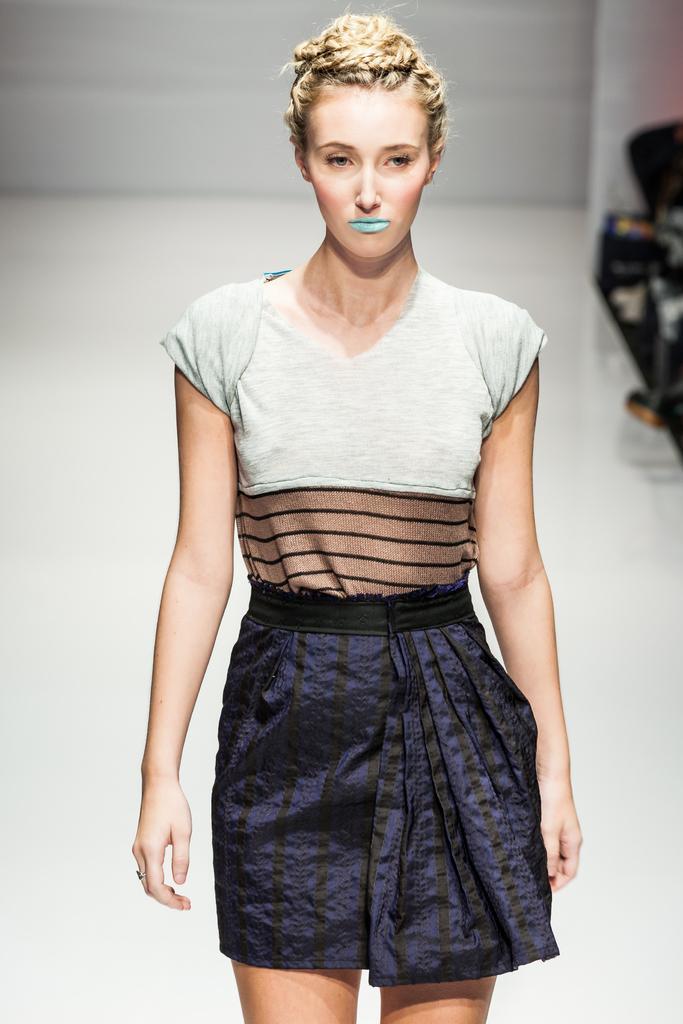Please provide a concise description of this image. In this image I see a woman who is wearing white, black, brown and purple color dress and in the background I see the white color floor and the wall. 